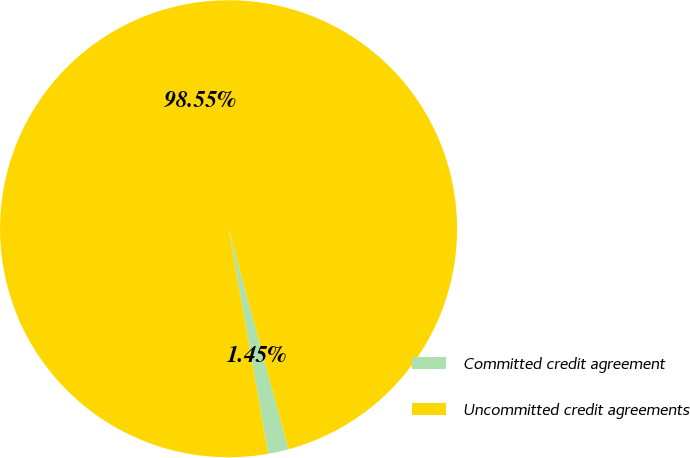Convert chart. <chart><loc_0><loc_0><loc_500><loc_500><pie_chart><fcel>Committed credit agreement<fcel>Uncommitted credit agreements<nl><fcel>1.45%<fcel>98.55%<nl></chart> 